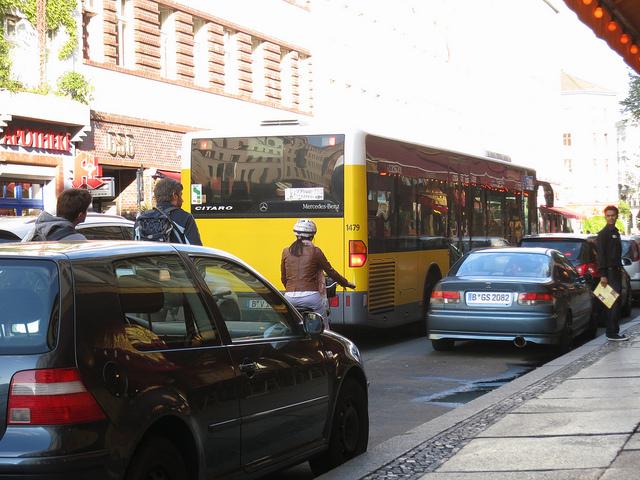What modes of transportation are present in this image? The image showcases a variety of transportation modes including bicycles, a bus, and a car. You can see several cyclists in the foreground, which suggests a bike-friendly area. The bus is prominent in the center of the street, indicating public transportation is an option here. Additionally, there is at least one car parked on the street. 